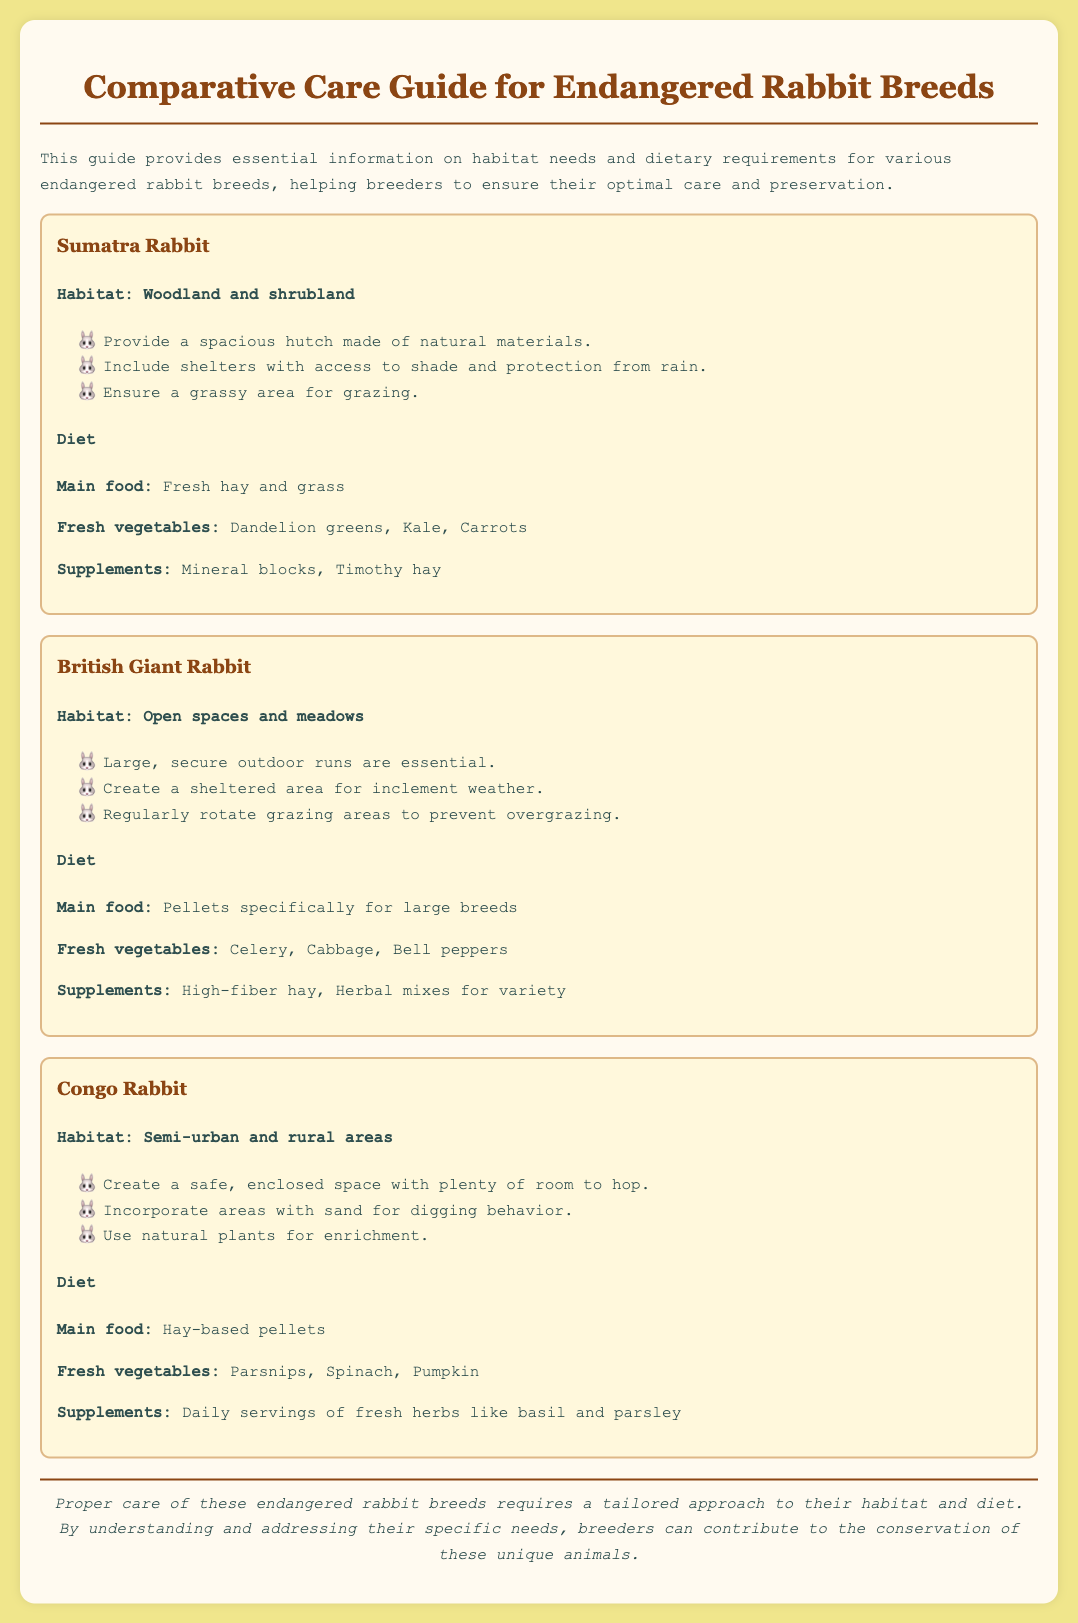What is the habitat of the Sumatra Rabbit? The habitat section specifies that the Sumatra Rabbit’s habitat includes woodland and shrubland.
Answer: Woodland and shrubland What is the main food for the British Giant Rabbit? The diet section states that the British Giant Rabbit's main food is pellets specifically for large breeds.
Answer: Pellets specifically for large breeds What dietary supplement is recommended for the Congo Rabbit? The diet section indicates that daily servings of fresh herbs like basil and parsley are recommended as a supplement.
Answer: Daily servings of fresh herbs like basil and parsley How should grazing areas be managed for the British Giant Rabbit? The habitat section mentions that grazing areas should be regularly rotated to prevent overgrazing.
Answer: Regularly rotate grazing areas What type of shelter is necessary for the Sumatra Rabbit? The habitat section states that shelters with access to shade and protection from rain are necessary.
Answer: Shelters with access to shade and protection from rain What is the purpose of providing a sandy area for the Congo Rabbit? The habitat section implies that incorporating areas with sand is for supporting digging behavior.
Answer: Supporting digging behavior What is the primary focus of this care guide? The document states that the guide provides essential information on habitat needs and dietary requirements for various endangered rabbit breeds.
Answer: Essential information on habitat needs and dietary requirements How does proper care affect endangered rabbit breeds? The conclusion indicates that proper care tailored to their specific needs contributes to the conservation of these unique animals.
Answer: Contributes to the conservation of these unique animals Which vegetable is suggested for the diet of the Congo Rabbit? The diet section specifies that parsnips are suggested as a fresh vegetable for the Congo Rabbit.
Answer: Parsnips 